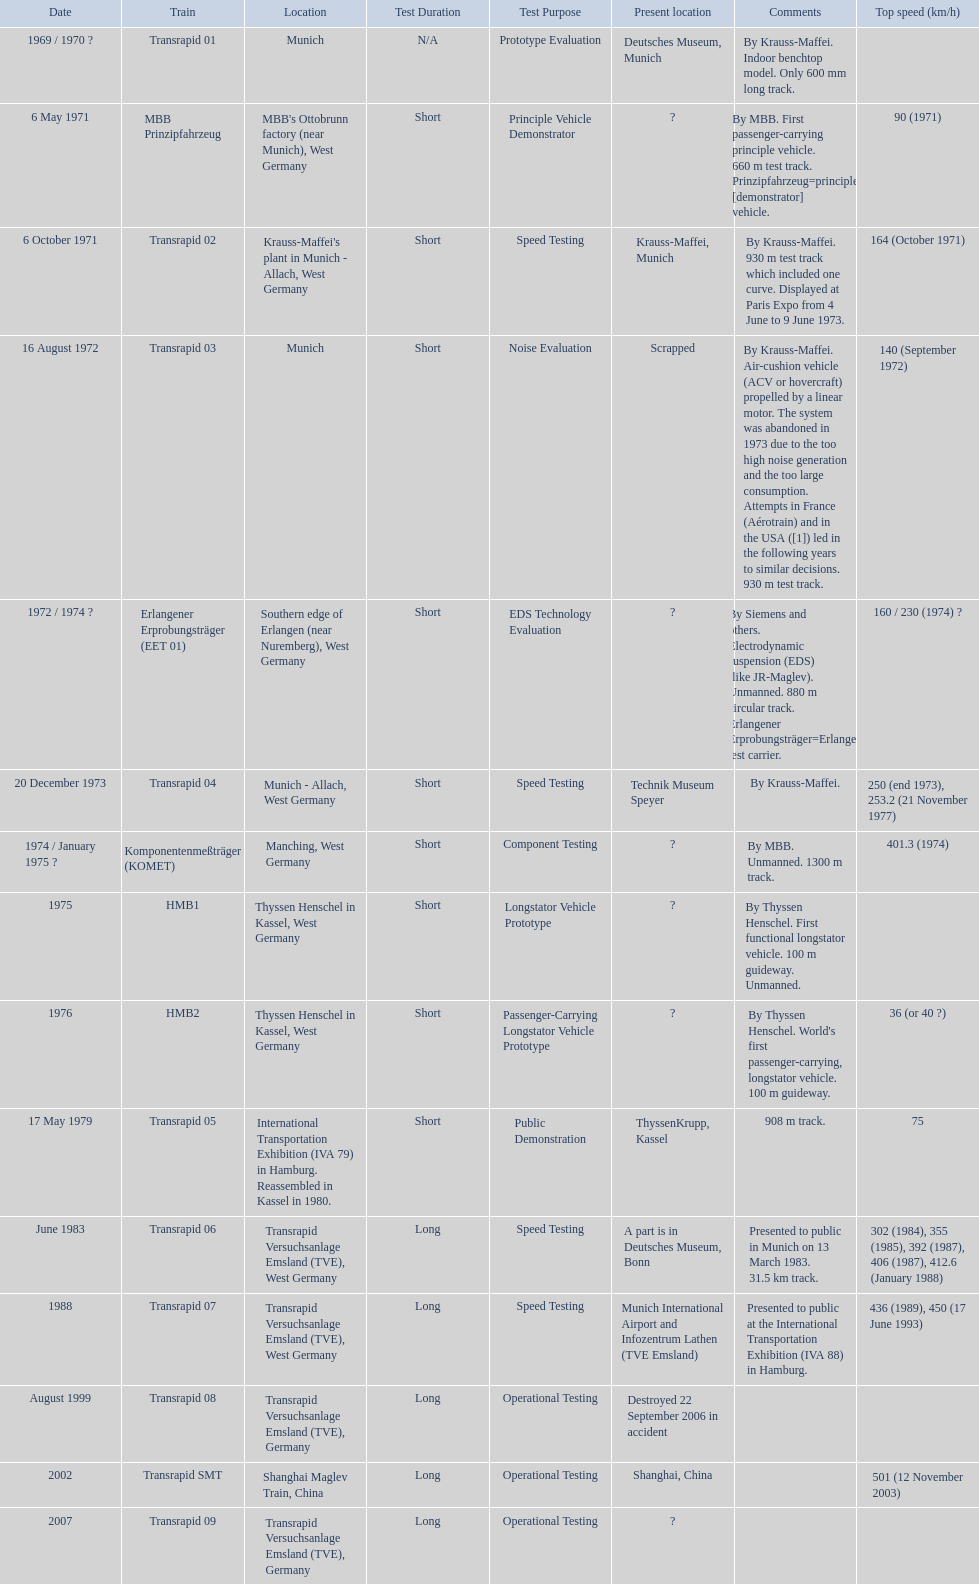Which trains exceeded a top speed of 400+? Komponentenmeßträger (KOMET), Transrapid 07, Transrapid SMT. How about 500+? Transrapid SMT. 